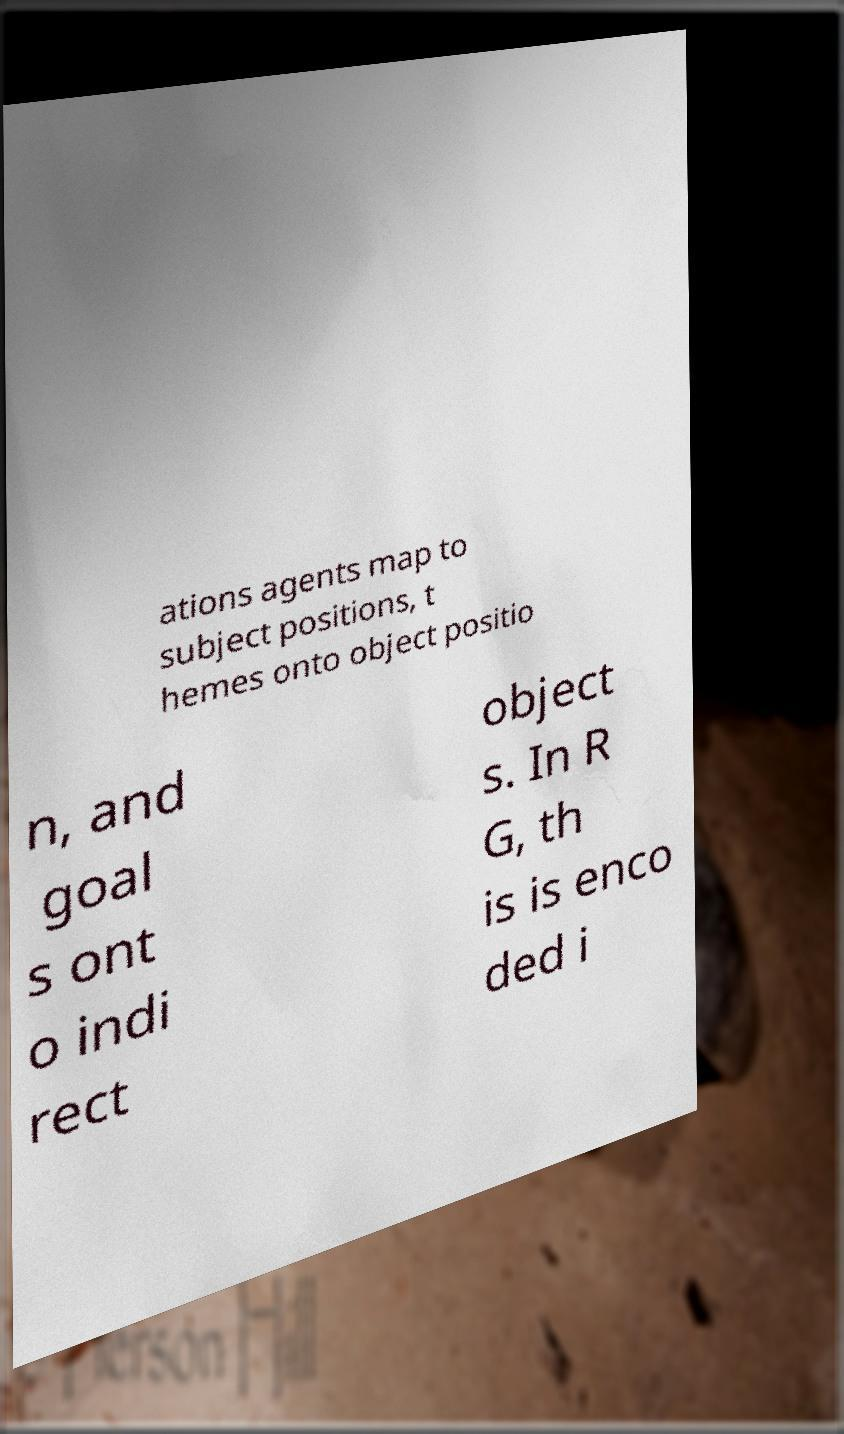What messages or text are displayed in this image? I need them in a readable, typed format. ations agents map to subject positions, t hemes onto object positio n, and goal s ont o indi rect object s. In R G, th is is enco ded i 